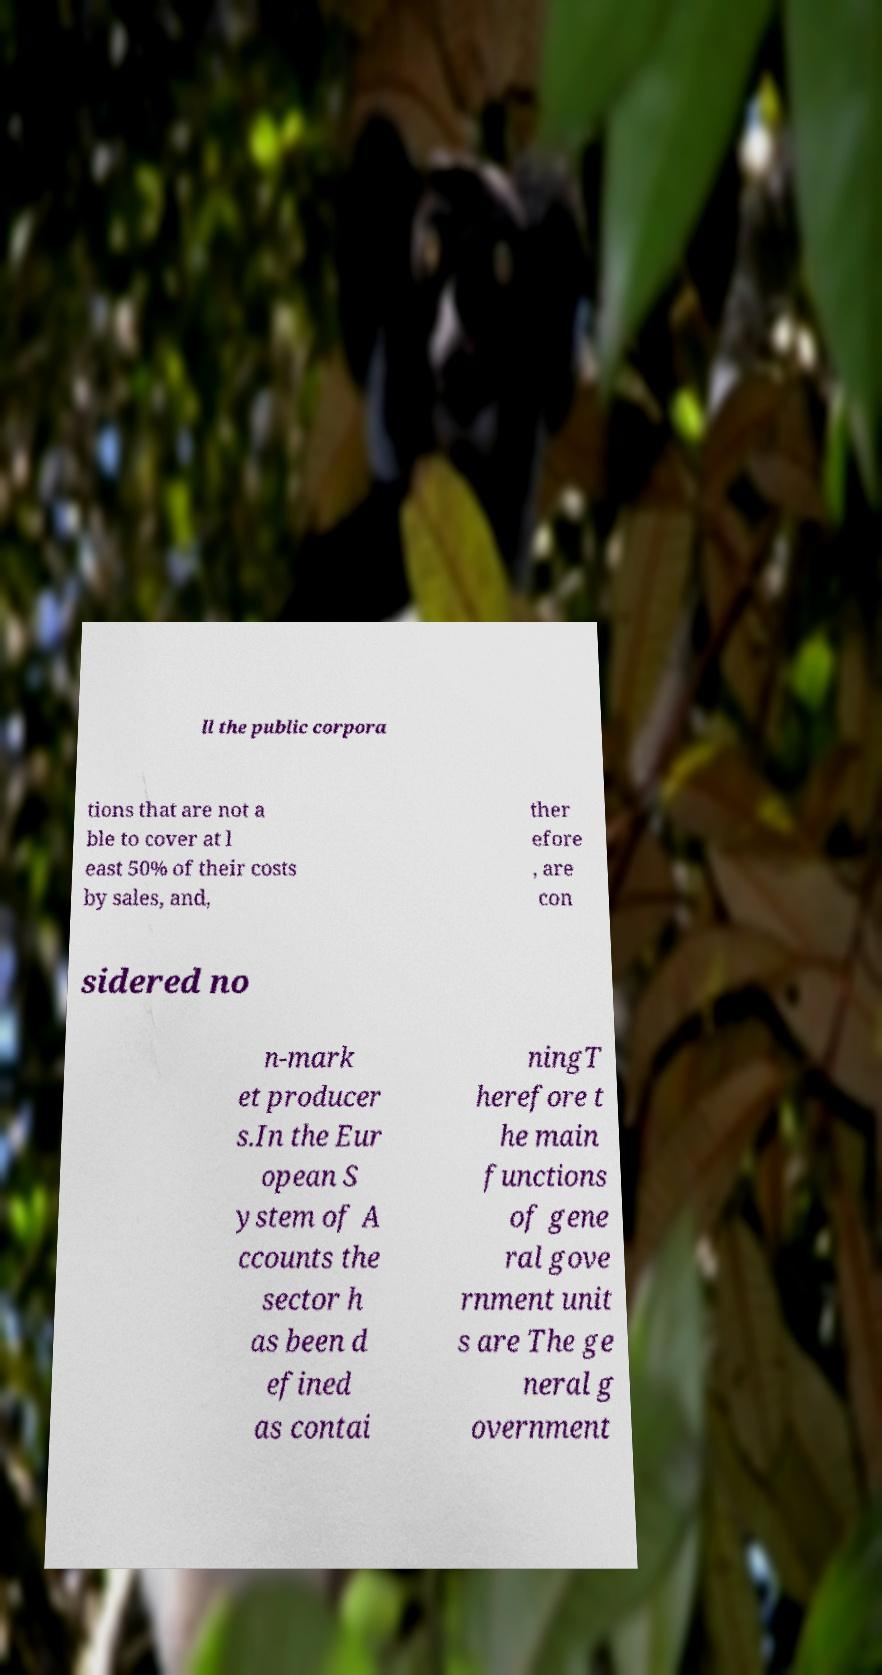Please identify and transcribe the text found in this image. ll the public corpora tions that are not a ble to cover at l east 50% of their costs by sales, and, ther efore , are con sidered no n-mark et producer s.In the Eur opean S ystem of A ccounts the sector h as been d efined as contai ningT herefore t he main functions of gene ral gove rnment unit s are The ge neral g overnment 